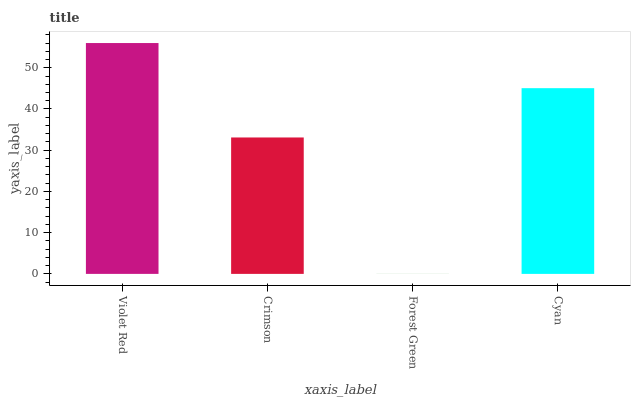Is Crimson the minimum?
Answer yes or no. No. Is Crimson the maximum?
Answer yes or no. No. Is Violet Red greater than Crimson?
Answer yes or no. Yes. Is Crimson less than Violet Red?
Answer yes or no. Yes. Is Crimson greater than Violet Red?
Answer yes or no. No. Is Violet Red less than Crimson?
Answer yes or no. No. Is Cyan the high median?
Answer yes or no. Yes. Is Crimson the low median?
Answer yes or no. Yes. Is Crimson the high median?
Answer yes or no. No. Is Violet Red the low median?
Answer yes or no. No. 